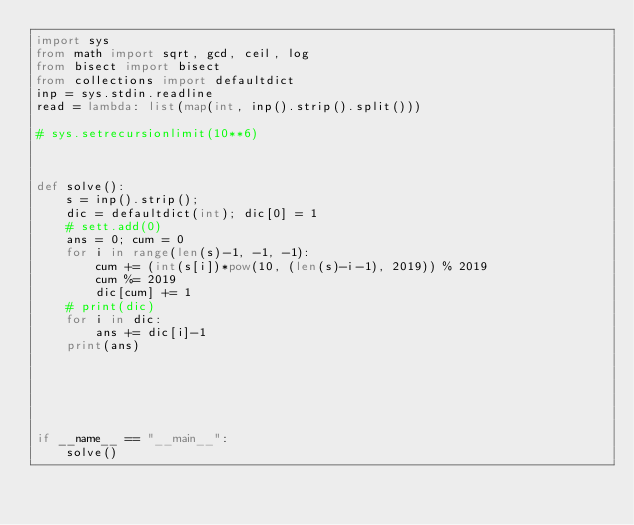<code> <loc_0><loc_0><loc_500><loc_500><_Python_>import sys
from math import sqrt, gcd, ceil, log
from bisect import bisect
from collections import defaultdict
inp = sys.stdin.readline
read = lambda: list(map(int, inp().strip().split()))

# sys.setrecursionlimit(10**6)



def solve():
	s = inp().strip();
	dic = defaultdict(int); dic[0] = 1
	# sett.add(0)
	ans = 0; cum = 0
	for i in range(len(s)-1, -1, -1):
		cum += (int(s[i])*pow(10, (len(s)-i-1), 2019)) % 2019
		cum %= 2019
		dic[cum] += 1
	# print(dic)
	for i in dic:
		ans += dic[i]-1
	print(ans)






if __name__ == "__main__":
	solve()</code> 